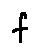Convert formula to latex. <formula><loc_0><loc_0><loc_500><loc_500>f</formula> 